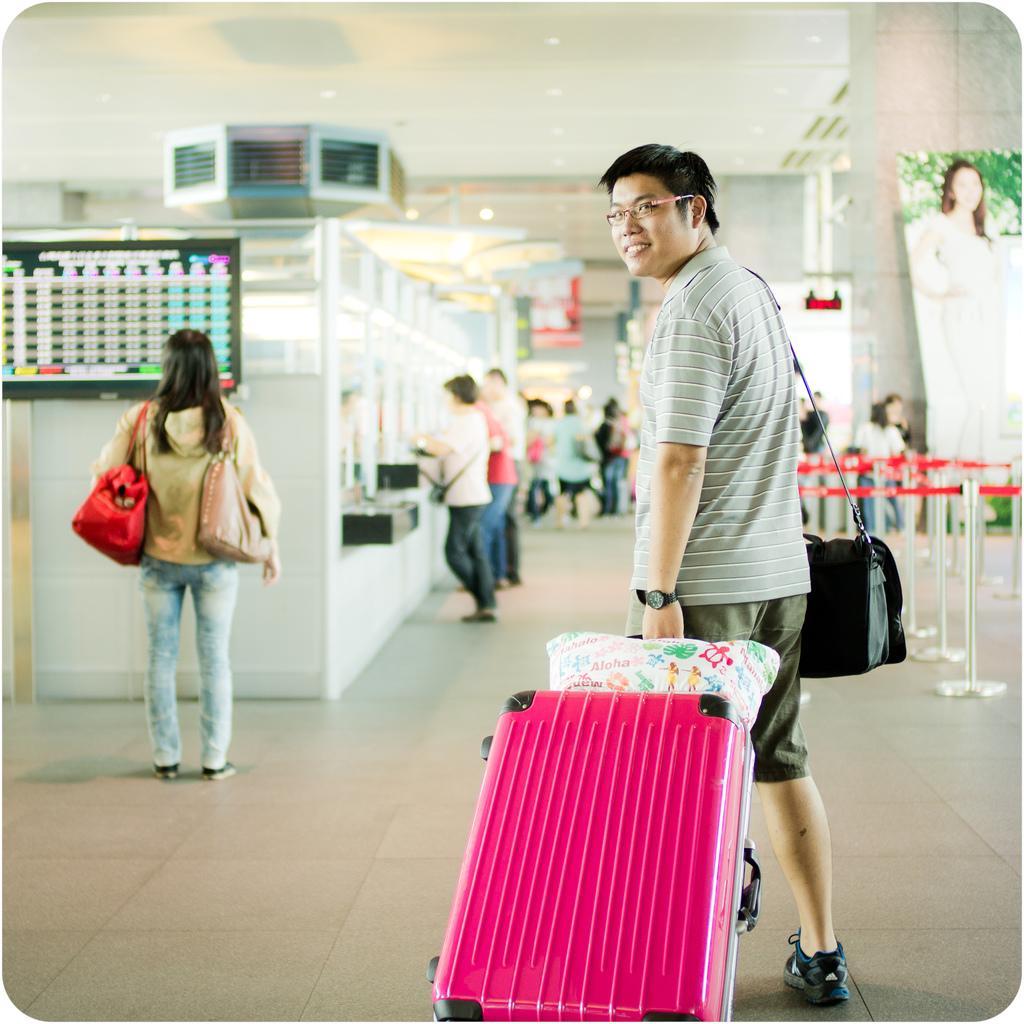Describe this image in one or two sentences. In the center we can see one man standing and holding trolley and he is smiling. On the left we can see one woman standing and holding handbag. In the background there is a screen,wall,sign boards,monitor,caution tape and few more persons were standing. 